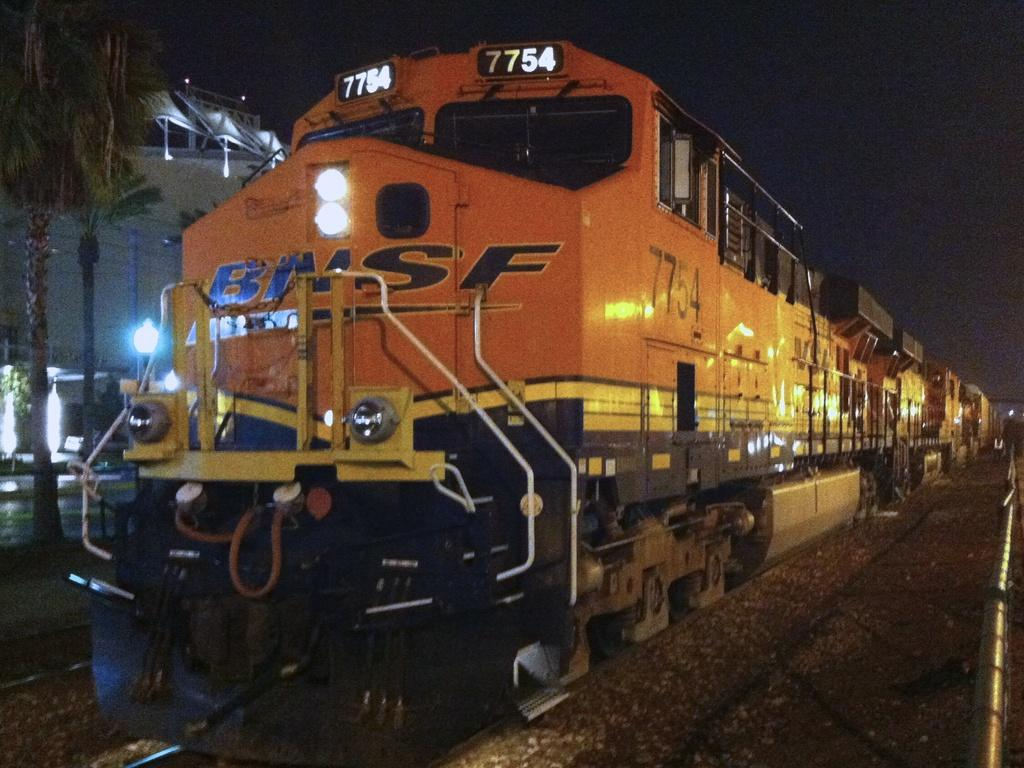What is the main subject of the image? The main subject of the image is a train. Where is the train located in the image? The train is on a railway track. What colors are used to paint the train? The train is in orange and yellow colors. What can be seen in the background of the image? There are trees, lights, and a building visible in the background. What type of lunch is being served in the train's dining car in the image? There is no dining car or lunch visible in the image; it only shows the train on a railway track. How does the train attract the attention of the passengers in the image? The train does not need to attract the attention of passengers in the image, as it is already the main subject. 